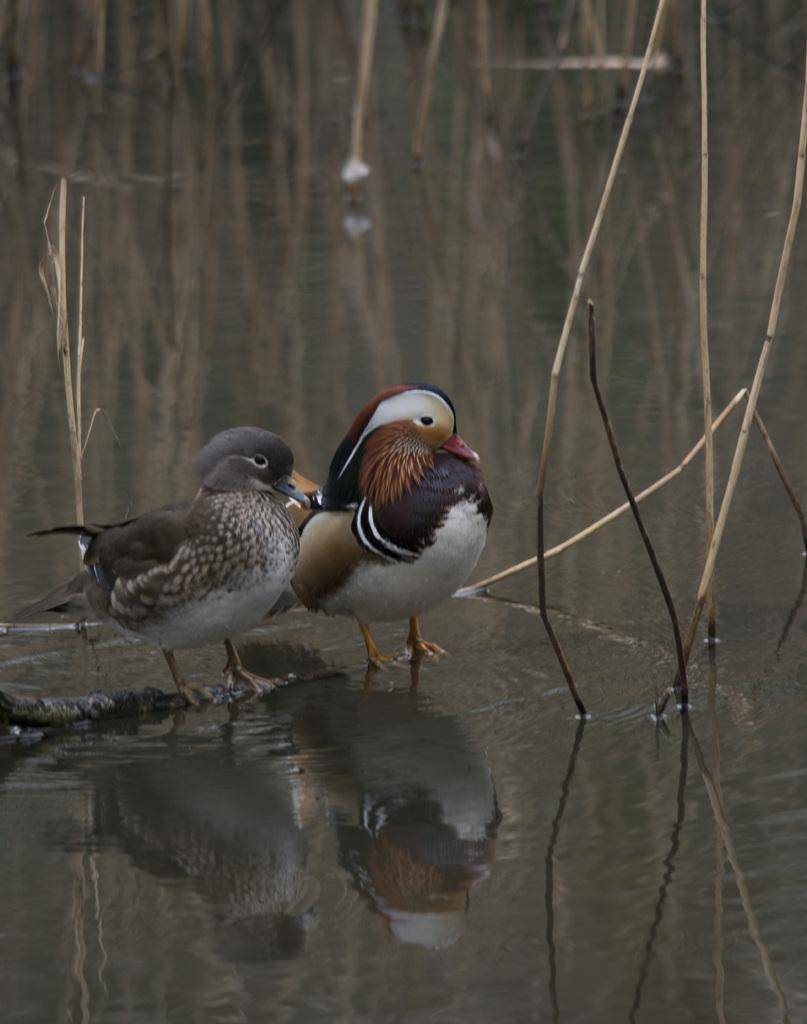How many birds are present in the image? There are two birds in the image. What type of natural environment can be seen in the image? There is grass and water visible in the image. What team do the birds belong to in the image? There is no indication in the image that the birds belong to a team. 